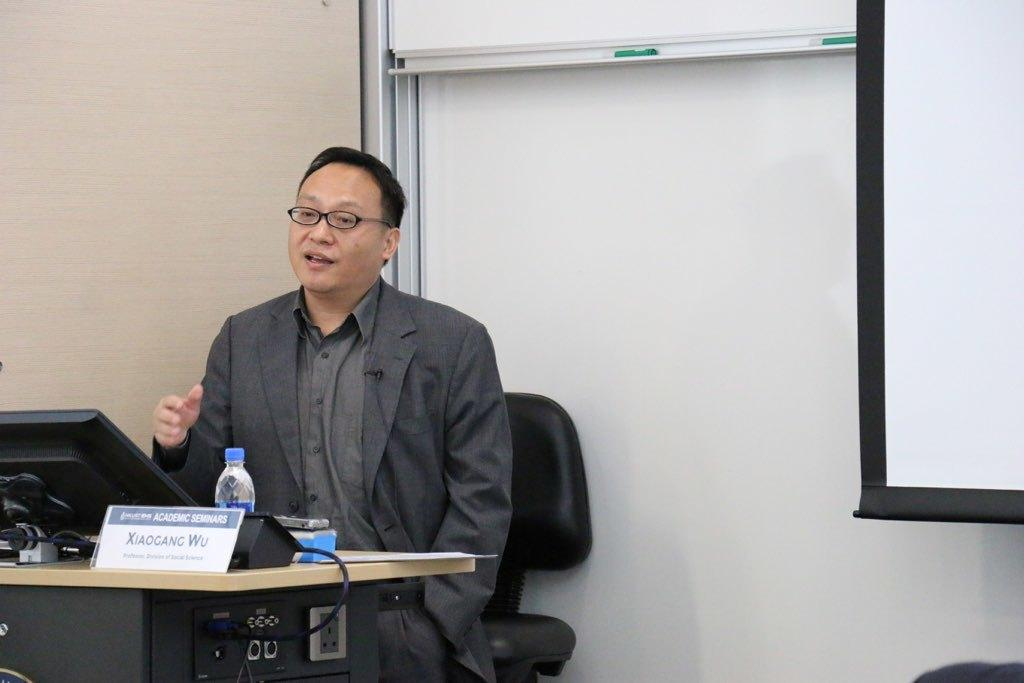What is the person in the image doing? The person is sitting on a chair. What is in front of the chair? There is a table in front of the chair. What items can be seen on the table can be seen in the image? There is a water bottle and a laptop on the table. What is visible behind the person and table? There is a wall visible in the image. What organization does the person's father work for in the image? There is no information about the person's father or any organization in the image. What is the sun doing in the image? The sun is not visible in the image, so its actions cannot be determined. 